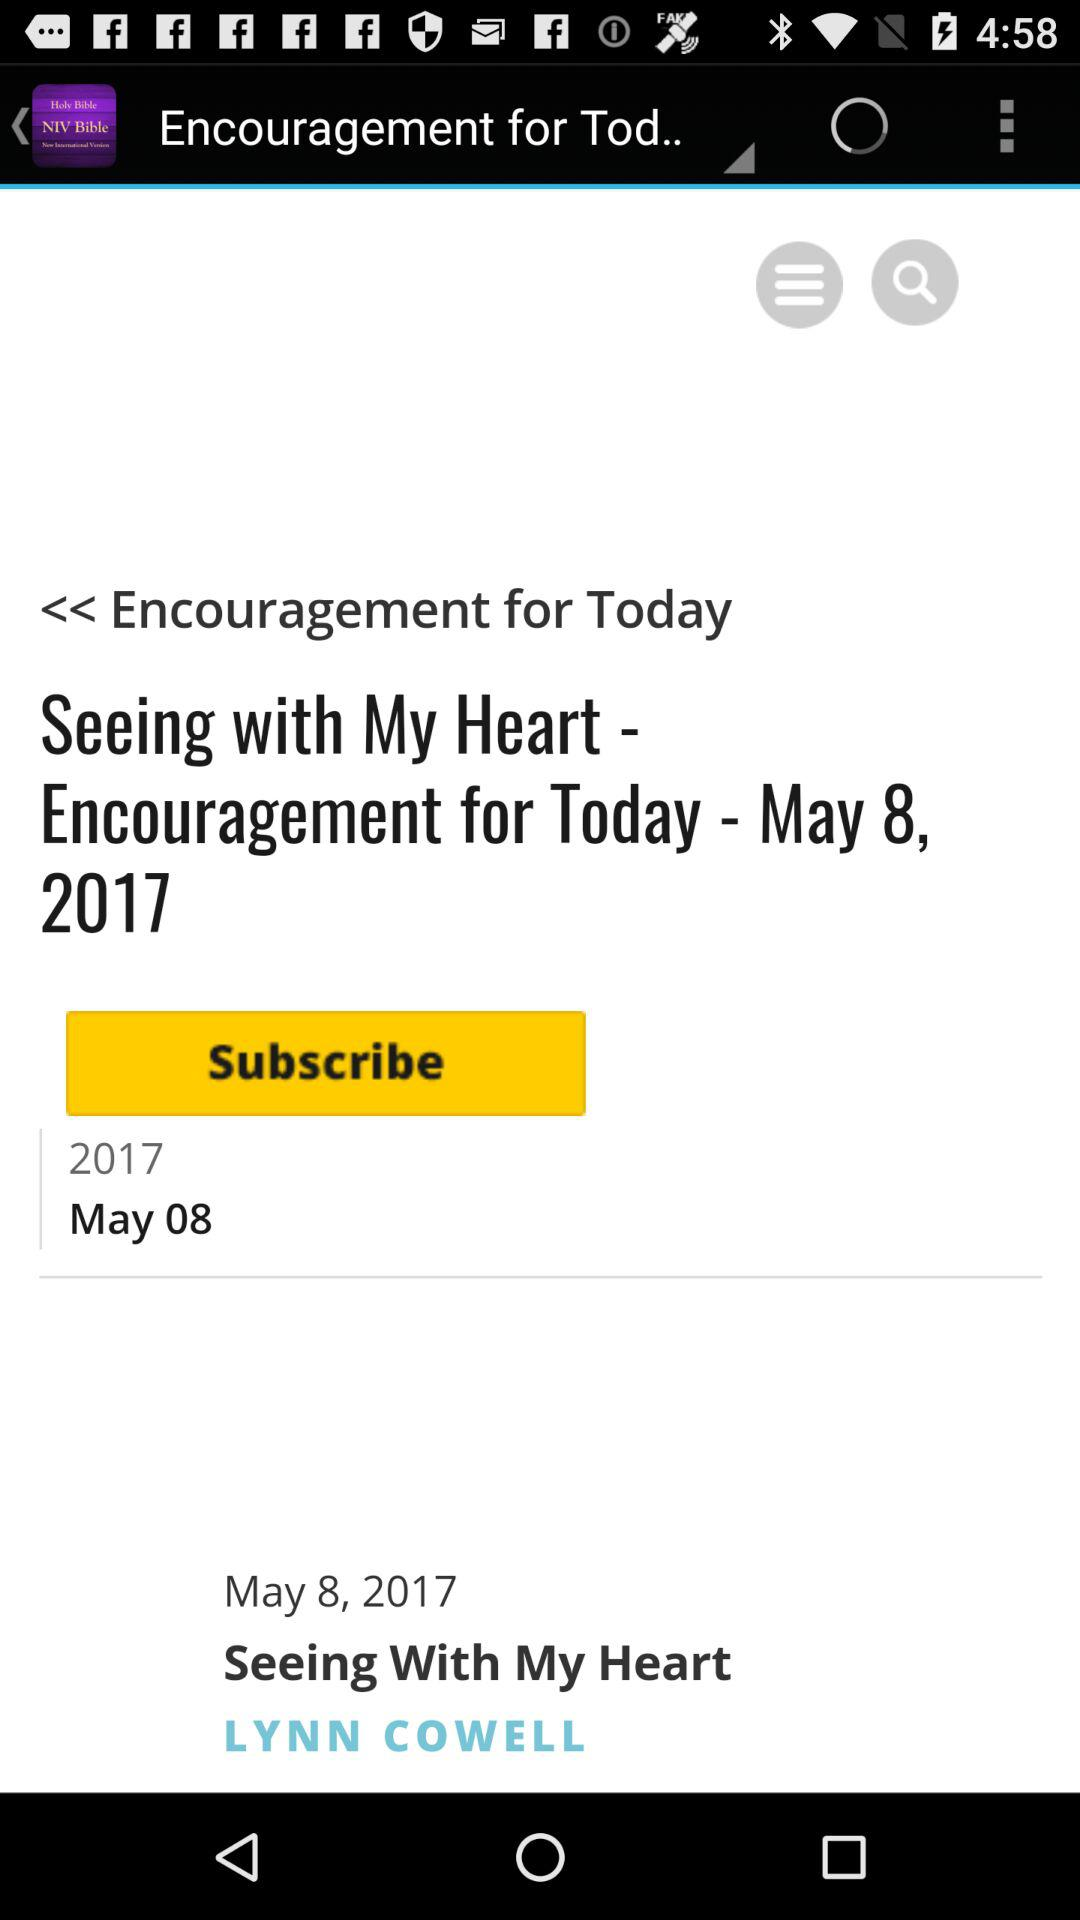What is the date? The date is May 8, 2017. 